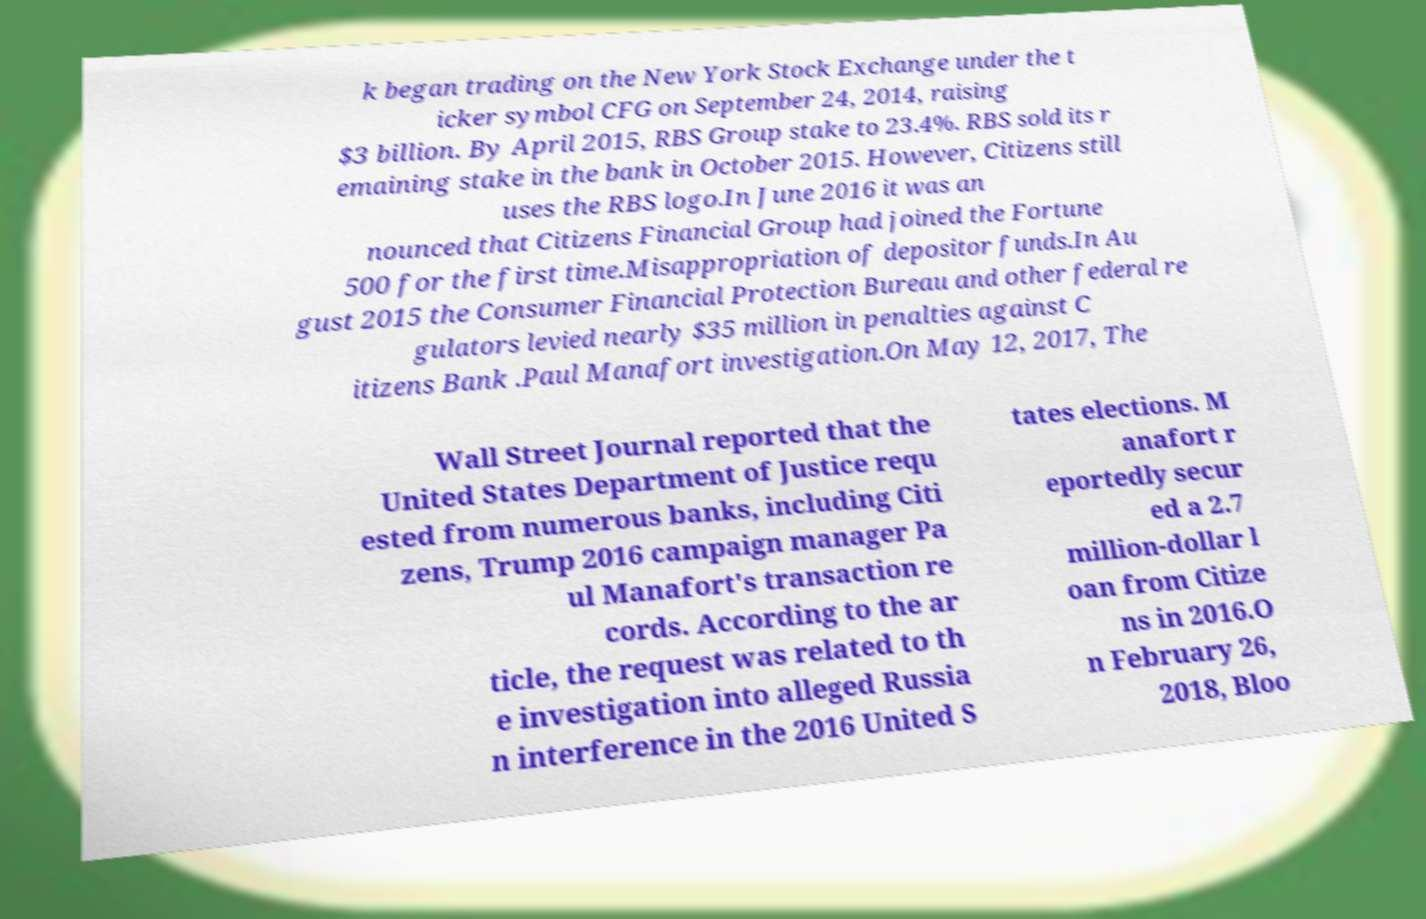There's text embedded in this image that I need extracted. Can you transcribe it verbatim? k began trading on the New York Stock Exchange under the t icker symbol CFG on September 24, 2014, raising $3 billion. By April 2015, RBS Group stake to 23.4%. RBS sold its r emaining stake in the bank in October 2015. However, Citizens still uses the RBS logo.In June 2016 it was an nounced that Citizens Financial Group had joined the Fortune 500 for the first time.Misappropriation of depositor funds.In Au gust 2015 the Consumer Financial Protection Bureau and other federal re gulators levied nearly $35 million in penalties against C itizens Bank .Paul Manafort investigation.On May 12, 2017, The Wall Street Journal reported that the United States Department of Justice requ ested from numerous banks, including Citi zens, Trump 2016 campaign manager Pa ul Manafort's transaction re cords. According to the ar ticle, the request was related to th e investigation into alleged Russia n interference in the 2016 United S tates elections. M anafort r eportedly secur ed a 2.7 million-dollar l oan from Citize ns in 2016.O n February 26, 2018, Bloo 